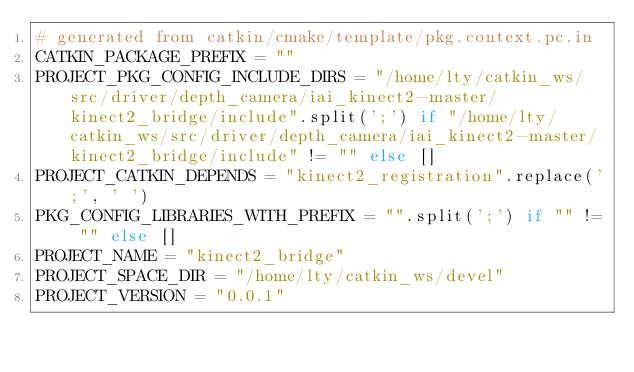<code> <loc_0><loc_0><loc_500><loc_500><_Python_># generated from catkin/cmake/template/pkg.context.pc.in
CATKIN_PACKAGE_PREFIX = ""
PROJECT_PKG_CONFIG_INCLUDE_DIRS = "/home/lty/catkin_ws/src/driver/depth_camera/iai_kinect2-master/kinect2_bridge/include".split(';') if "/home/lty/catkin_ws/src/driver/depth_camera/iai_kinect2-master/kinect2_bridge/include" != "" else []
PROJECT_CATKIN_DEPENDS = "kinect2_registration".replace(';', ' ')
PKG_CONFIG_LIBRARIES_WITH_PREFIX = "".split(';') if "" != "" else []
PROJECT_NAME = "kinect2_bridge"
PROJECT_SPACE_DIR = "/home/lty/catkin_ws/devel"
PROJECT_VERSION = "0.0.1"
</code> 